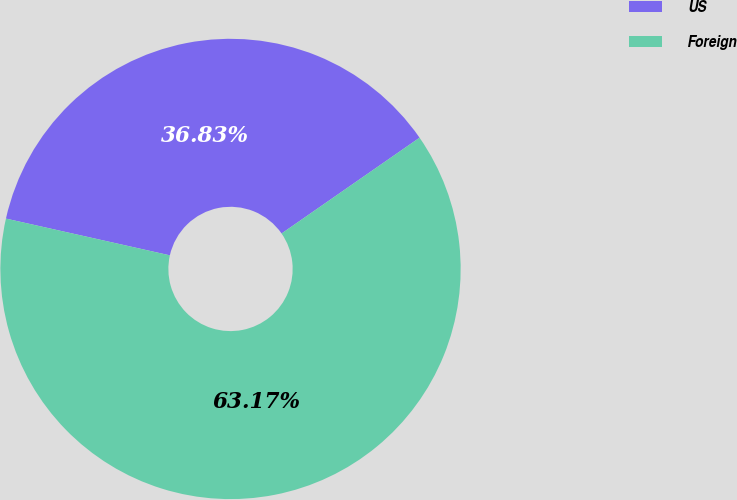<chart> <loc_0><loc_0><loc_500><loc_500><pie_chart><fcel>US<fcel>Foreign<nl><fcel>36.83%<fcel>63.17%<nl></chart> 